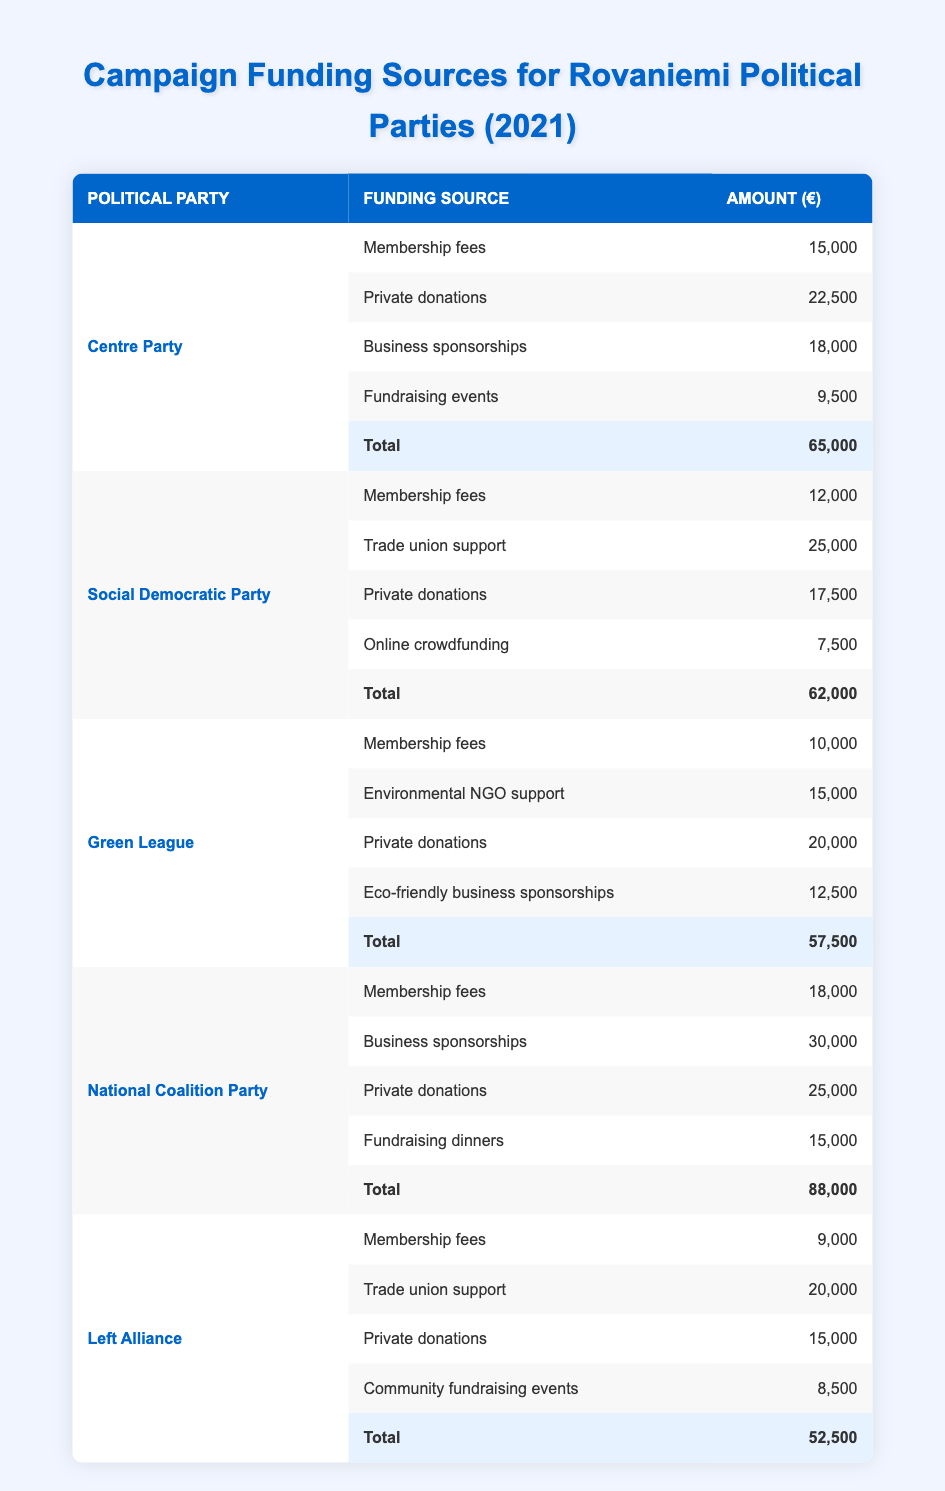What was the total funding for the National Coalition Party? The National Coalition Party has four funding sources. We see their amounts as follows: Membership fees (18,000), Business sponsorships (30,000), Private donations (25,000), and Fundraising dinners (15,000). Adding these amounts gives: 18,000 + 30,000 + 25,000 + 15,000 = 88,000.
Answer: 88,000 Which party received the highest amount from business sponsorships? From the table, we see that the National Coalition Party received 30,000 from business sponsorships, which is higher than Centre Party (18,000) and Green League (12,500). Thus, they received the highest amount from this funding source.
Answer: National Coalition Party Did the Green League receive more in private donations than the Social Democratic Party? The Green League received 20,000 in private donations, while the Social Democratic Party received 17,500. Since 20,000 is greater than 17,500, the statement is true.
Answer: Yes What is the total amount of funding from membership fees for all parties combined? The amounts from each party are: Centre Party (15,000), Social Democratic Party (12,000), Green League (10,000), National Coalition Party (18,000), and Left Alliance (9,000). Adding these amounts gives: 15,000 + 12,000 + 10,000 + 18,000 + 9,000 = 64,000.
Answer: 64,000 Which funding source provided the least amount of funding for the Left Alliance? Checking the funding sources for the Left Alliance, we find: Membership fees (9,000), Trade union support (20,000), Private donations (15,000), and Community fundraising events (8,500). Among these, the least amount is from Community fundraising events at 8,500.
Answer: Community fundraising events What was the average amount raised through fundraising events across all parties? The only fundraising event amounts are: Centre Party (9,500), Social Democratic Party (7,500), and National Coalition Party (15,000). Calculating the average: (9,500 + 7,500 + 15,000) / 3 = 32,000 / 3 = approximately 10,667.
Answer: Approximately 10,667 Which party had the lowest total funding overall? The totals for each party are: Centre Party (65,000), Social Democratic Party (62,000), Green League (57,500), National Coalition Party (88,000), and Left Alliance (52,500). The Left Alliance has the lowest total at 52,500.
Answer: Left Alliance Does the Social Democratic Party have a total funding above 70,000? The total funding for the Social Democratic Party is 62,000, which is less than 70,000. Therefore, the statement is false.
Answer: No 